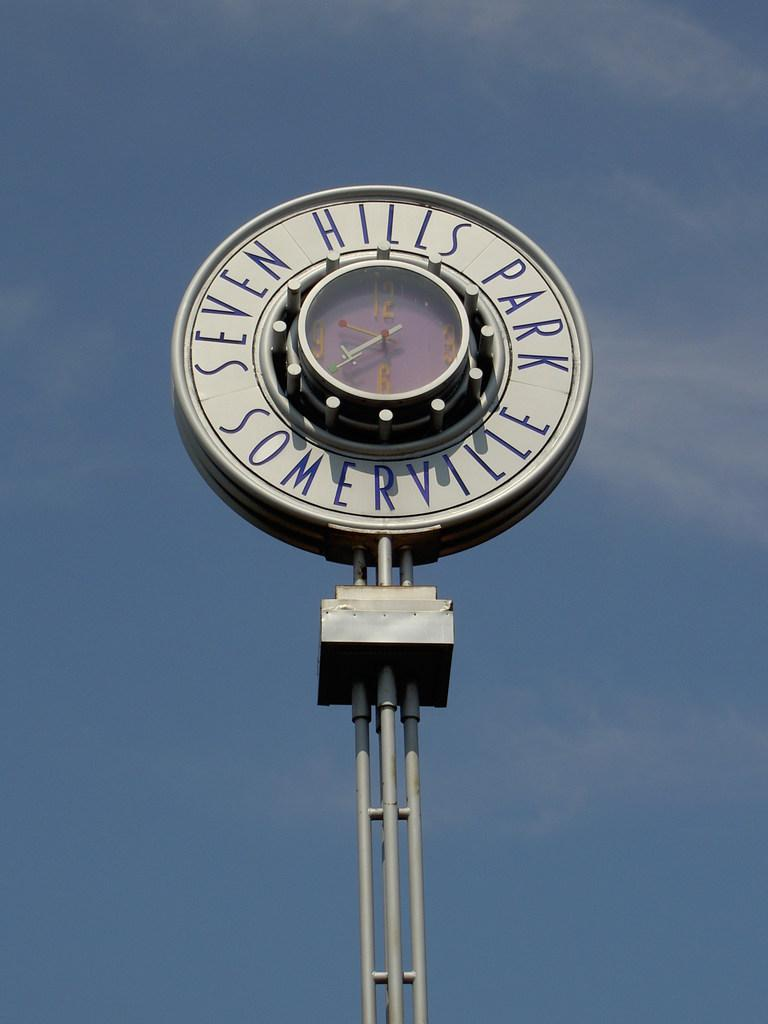<image>
Create a compact narrative representing the image presented. A round sign for Seven Hills Park has a clock in the center. 